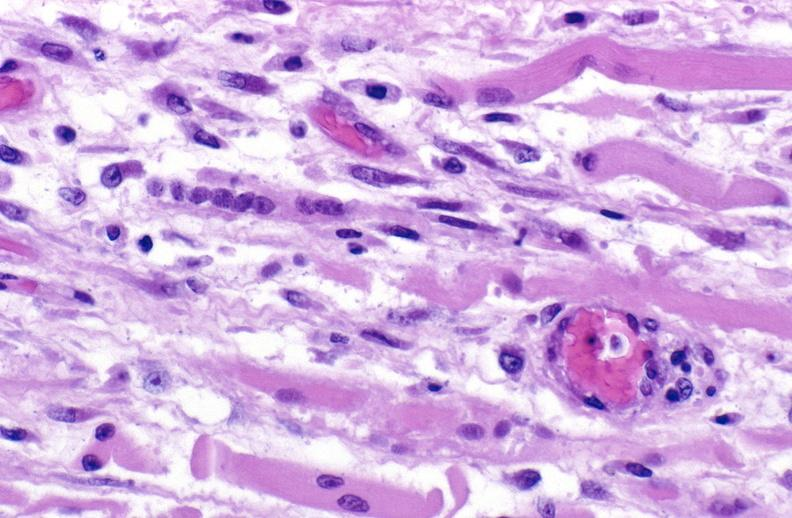what is present?
Answer the question using a single word or phrase. Soft tissue 